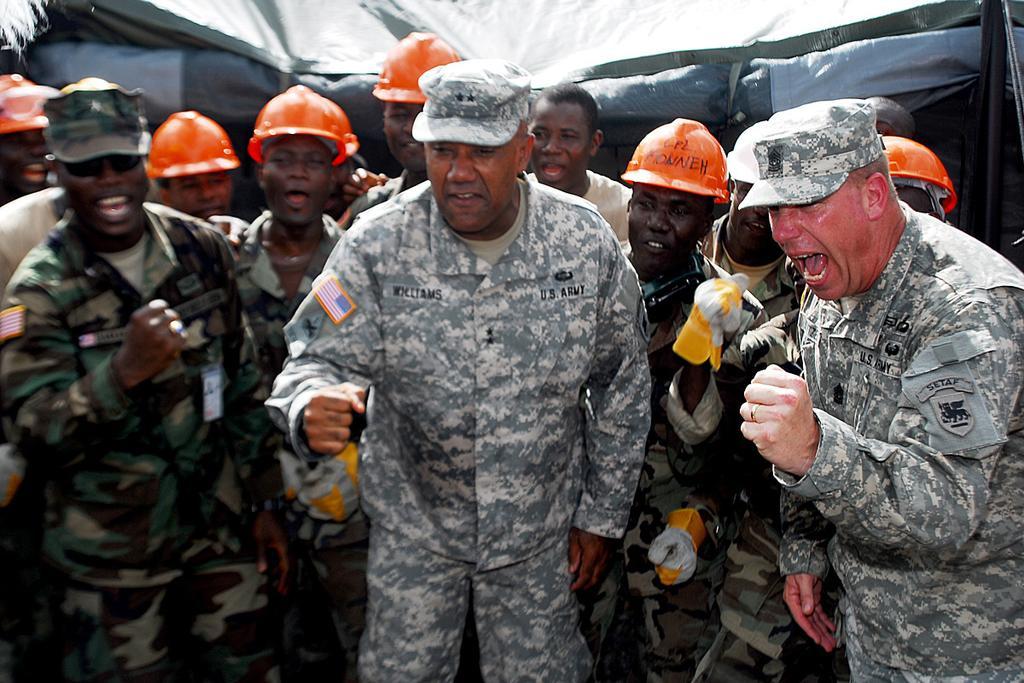Describe this image in one or two sentences. In this image, we can see a group of people standing. In the background, we can see black color tint. 